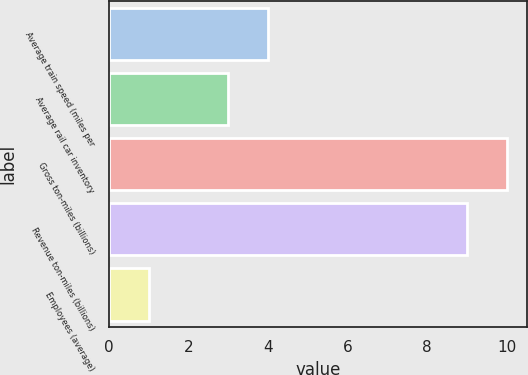Convert chart to OTSL. <chart><loc_0><loc_0><loc_500><loc_500><bar_chart><fcel>Average train speed (miles per<fcel>Average rail car inventory<fcel>Gross ton-miles (billions)<fcel>Revenue ton-miles (billions)<fcel>Employees (average)<nl><fcel>4<fcel>3<fcel>10<fcel>9<fcel>1<nl></chart> 